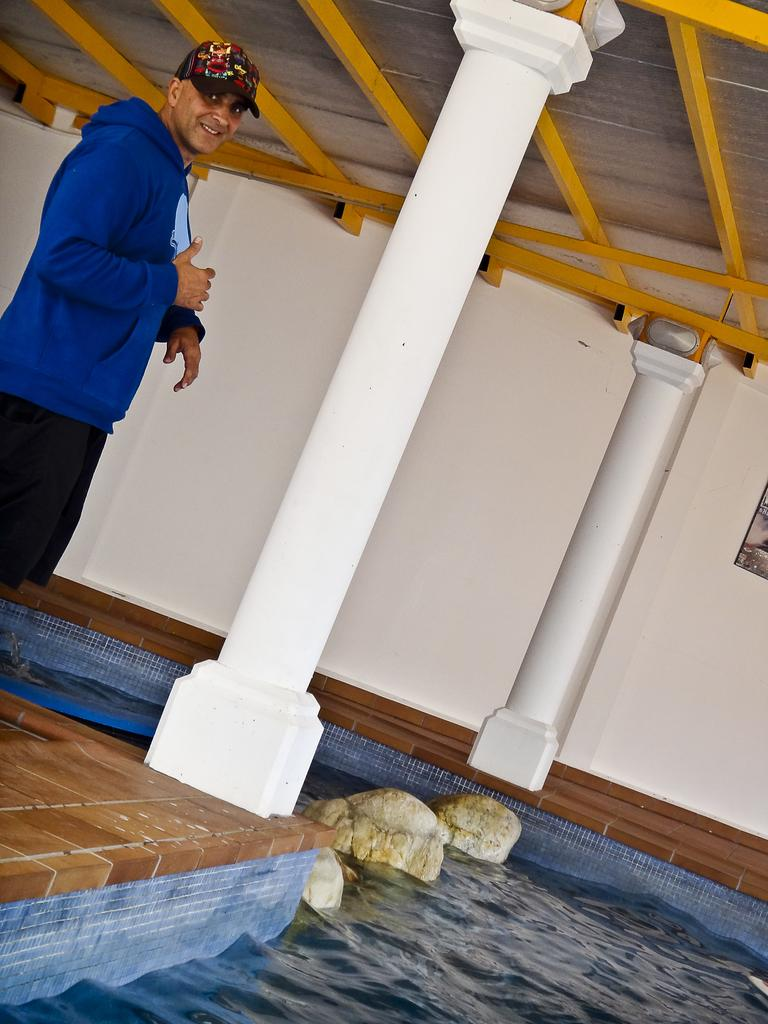What is present in the image that serves as a background or boundary? There is a wall in the image. What soft objects can be seen in the image? There are pillows in the image. Who is present in the image? There is a man in the image. What is the man wearing that is blue? The man is wearing a blue jacket. How many eyes are visible on the paper in the image? There is no paper or eyes present in the image. What type of afterthought is depicted on the wall in the image? There is no afterthought depicted in the image; it only features a wall, pillows, and a man wearing a blue jacket. 